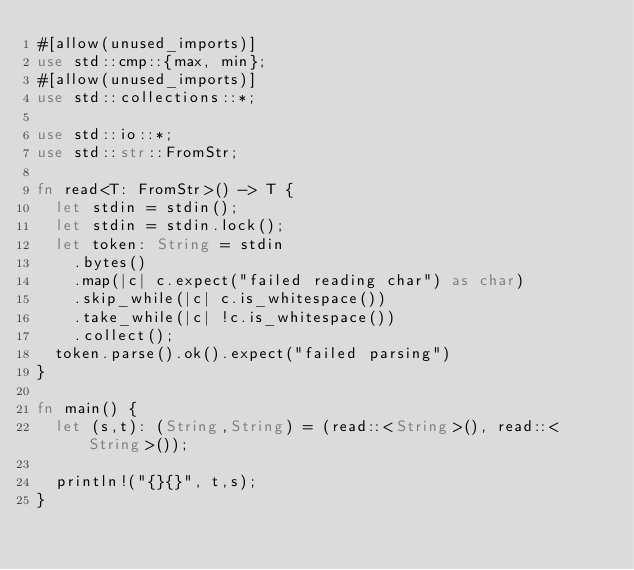Convert code to text. <code><loc_0><loc_0><loc_500><loc_500><_Rust_>#[allow(unused_imports)]
use std::cmp::{max, min};
#[allow(unused_imports)]
use std::collections::*;

use std::io::*;
use std::str::FromStr;

fn read<T: FromStr>() -> T {
  let stdin = stdin();
  let stdin = stdin.lock();
  let token: String = stdin
    .bytes()
    .map(|c| c.expect("failed reading char") as char)
    .skip_while(|c| c.is_whitespace())
    .take_while(|c| !c.is_whitespace())
    .collect();
  token.parse().ok().expect("failed parsing")
}

fn main() {
  let (s,t): (String,String) = (read::<String>(), read::<String>());

  println!("{}{}", t,s);
}
</code> 